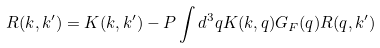Convert formula to latex. <formula><loc_0><loc_0><loc_500><loc_500>R ( k , k ^ { \prime } ) = K ( k , k ^ { \prime } ) - P \int d ^ { 3 } q K ( k , q ) G _ { F } ( q ) R ( q , k ^ { \prime } )</formula> 